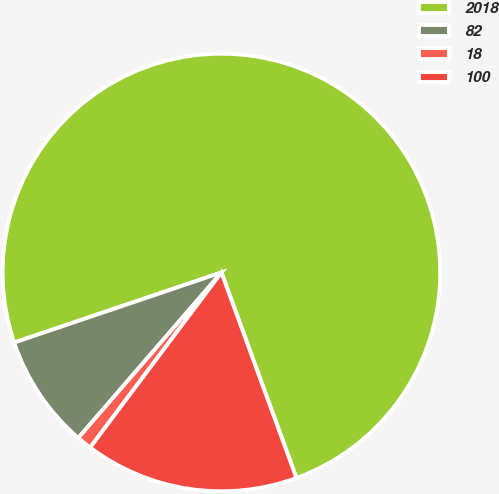Convert chart to OTSL. <chart><loc_0><loc_0><loc_500><loc_500><pie_chart><fcel>2018<fcel>82<fcel>18<fcel>100<nl><fcel>74.62%<fcel>8.46%<fcel>1.11%<fcel>15.81%<nl></chart> 